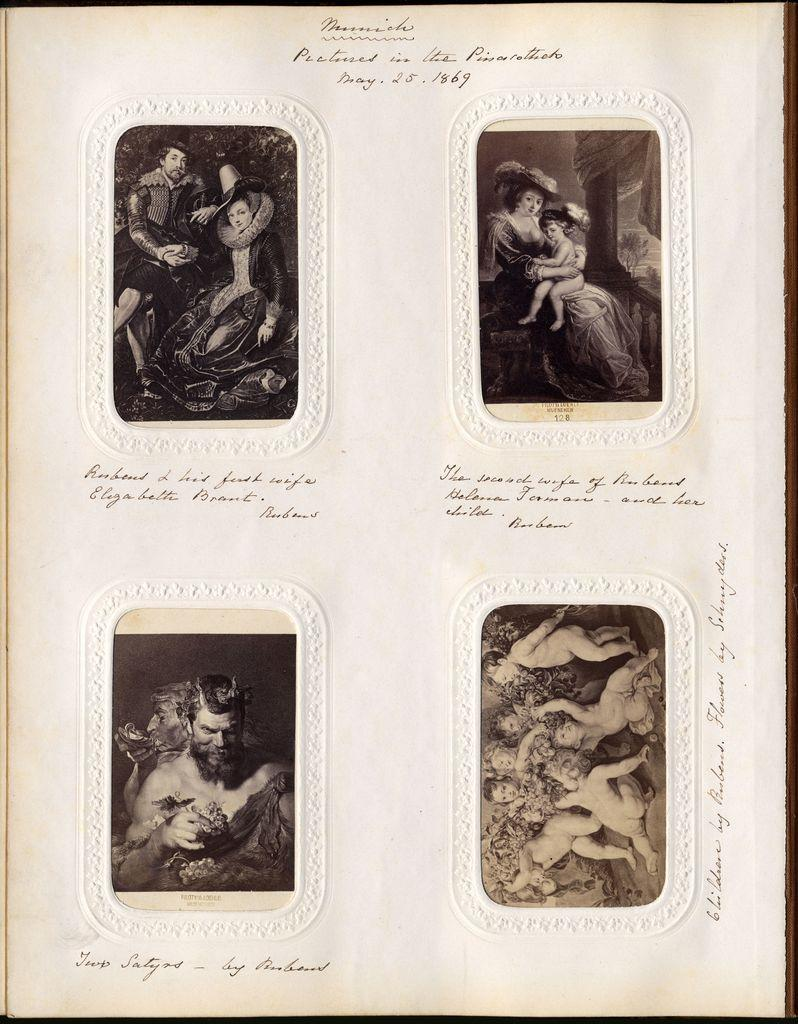What is present in the image that contains information? There is a paper in the image that contains information. What types of content can be found on the paper? The paper contains images and text. How many brothers are depicted in the images on the paper? There is no information about brothers in the images on the paper, as the facts provided only mention the presence of images and text on the paper. 